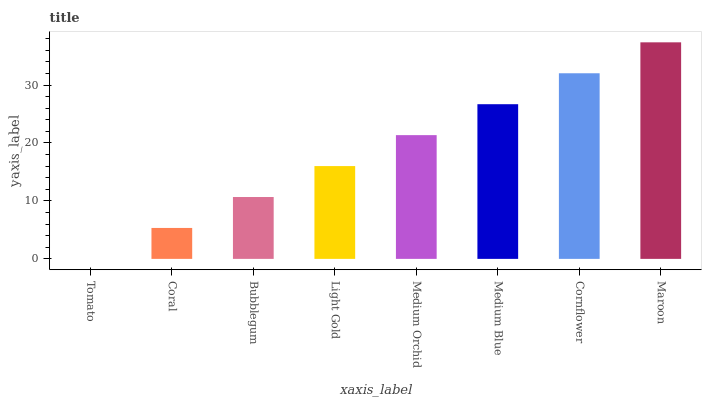Is Tomato the minimum?
Answer yes or no. Yes. Is Maroon the maximum?
Answer yes or no. Yes. Is Coral the minimum?
Answer yes or no. No. Is Coral the maximum?
Answer yes or no. No. Is Coral greater than Tomato?
Answer yes or no. Yes. Is Tomato less than Coral?
Answer yes or no. Yes. Is Tomato greater than Coral?
Answer yes or no. No. Is Coral less than Tomato?
Answer yes or no. No. Is Medium Orchid the high median?
Answer yes or no. Yes. Is Light Gold the low median?
Answer yes or no. Yes. Is Maroon the high median?
Answer yes or no. No. Is Maroon the low median?
Answer yes or no. No. 